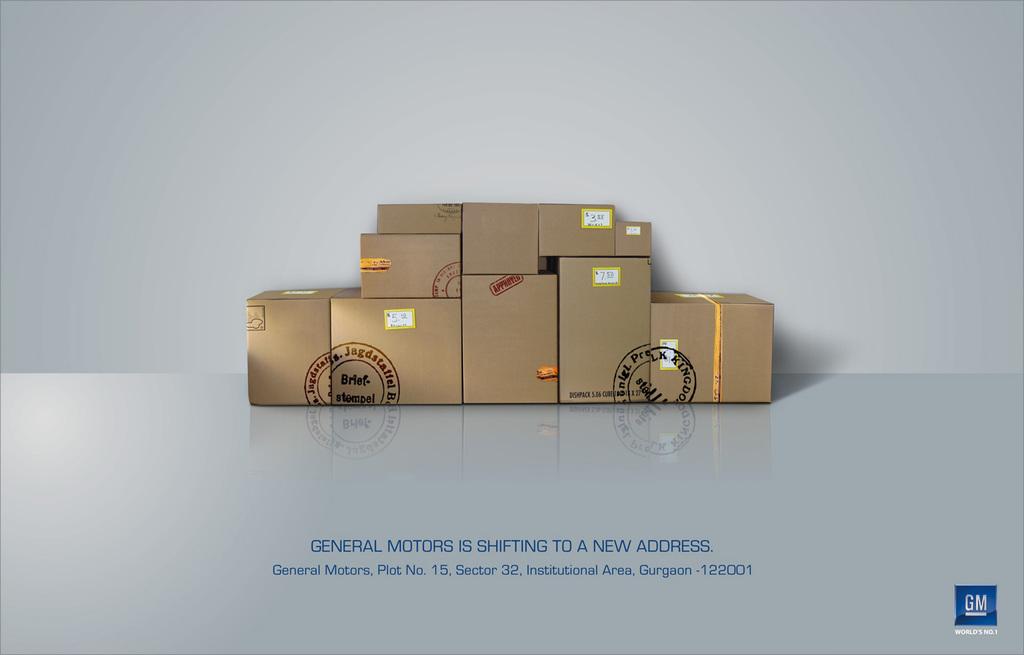What car company is this for?
Provide a short and direct response. Gm. What plot number is gm at?
Your answer should be very brief. 15. 